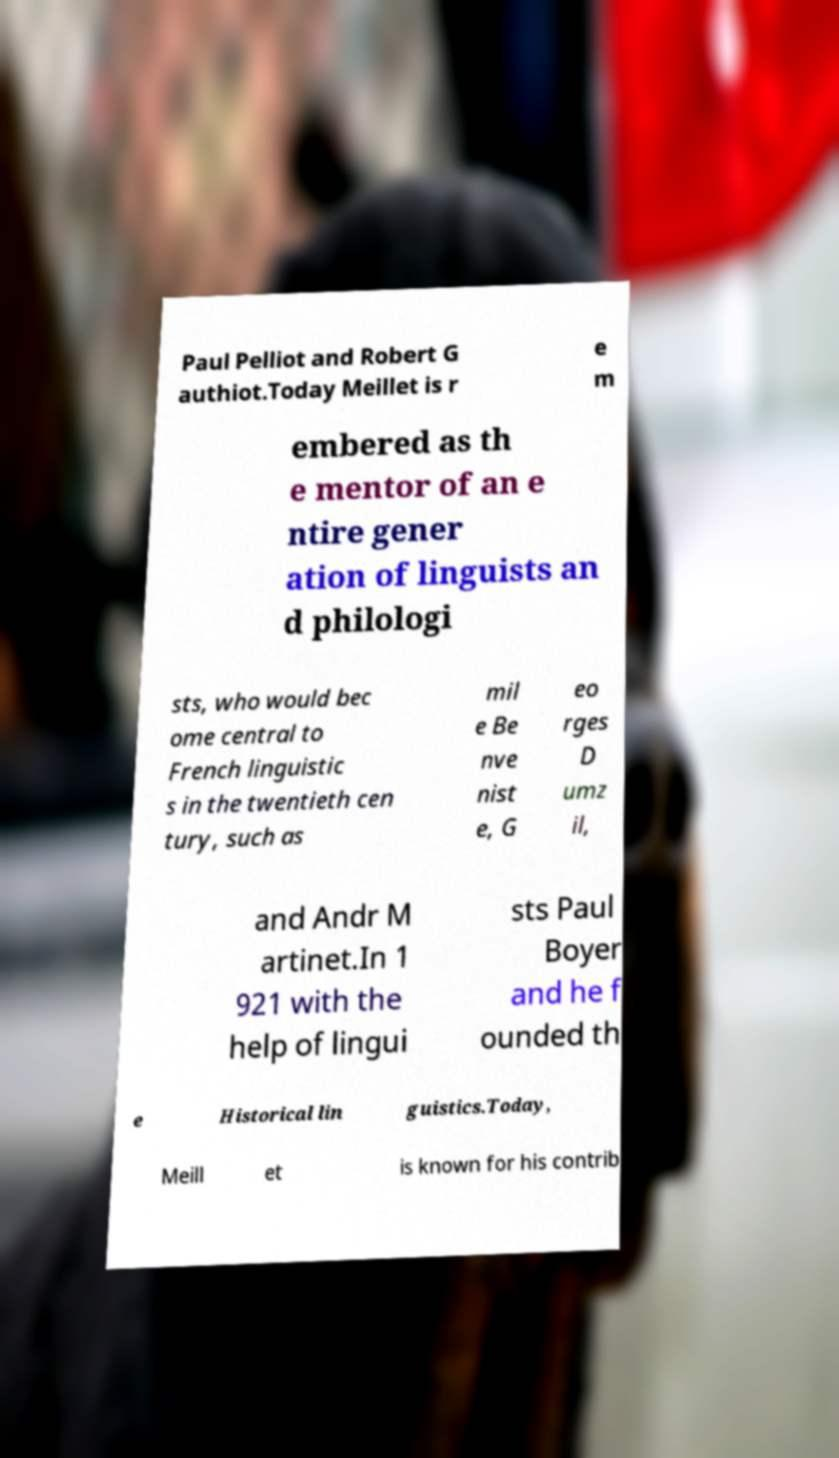Could you extract and type out the text from this image? Paul Pelliot and Robert G authiot.Today Meillet is r e m embered as th e mentor of an e ntire gener ation of linguists an d philologi sts, who would bec ome central to French linguistic s in the twentieth cen tury, such as mil e Be nve nist e, G eo rges D umz il, and Andr M artinet.In 1 921 with the help of lingui sts Paul Boyer and he f ounded th e Historical lin guistics.Today, Meill et is known for his contrib 